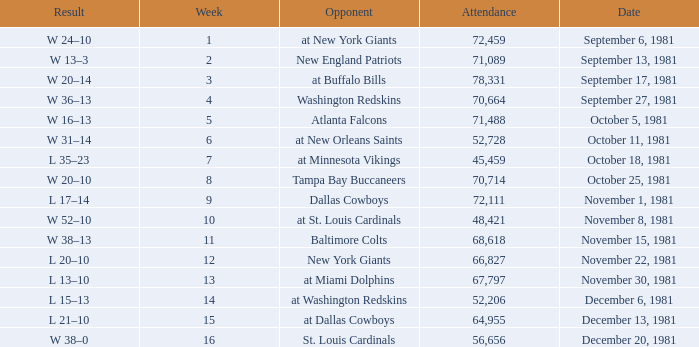What is the average Attendance, when the Date is September 17, 1981? 78331.0. 